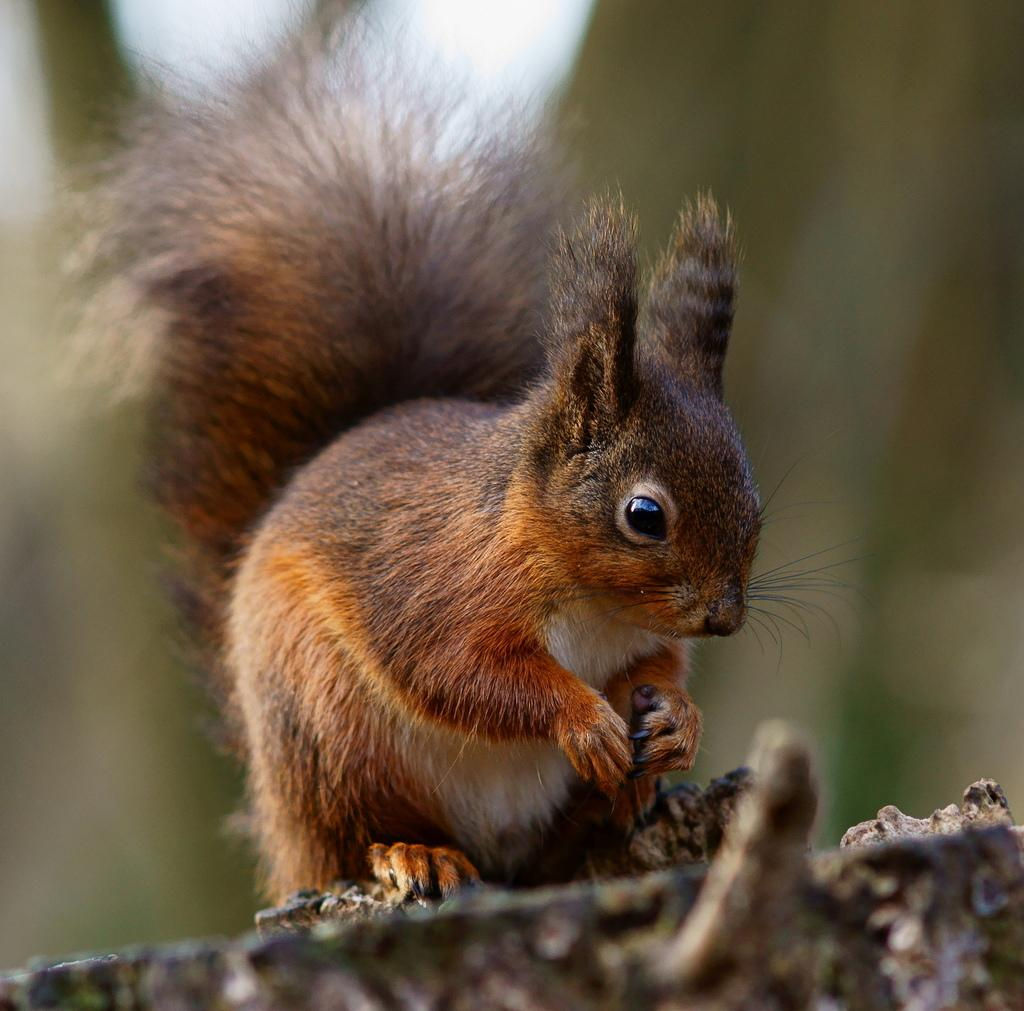What type of animal is in the image? There is a squirrel in the image. Where is the squirrel located in the image? The squirrel is on the surface. Can you describe the background of the image? The background of the image is blurred. What type of business can be seen operating on the sidewalk in the image? There is no business or sidewalk present in the image; it features a squirrel on a surface with a blurred background. What type of smoke is visible coming from the squirrel in the image? There is no smoke present in the image; it features a squirrel on a surface with a blurred background. 